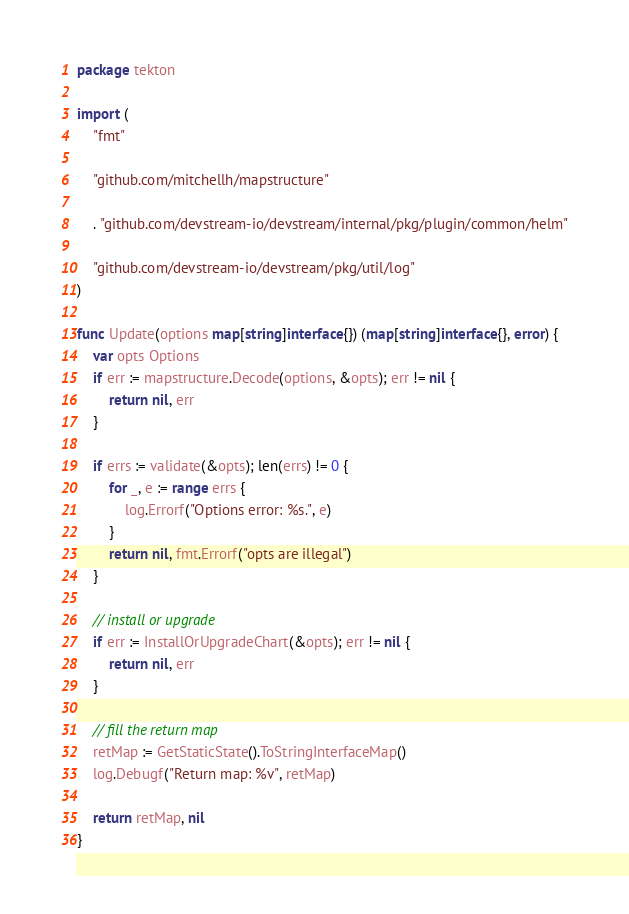<code> <loc_0><loc_0><loc_500><loc_500><_Go_>package tekton

import (
	"fmt"

	"github.com/mitchellh/mapstructure"

	. "github.com/devstream-io/devstream/internal/pkg/plugin/common/helm"

	"github.com/devstream-io/devstream/pkg/util/log"
)

func Update(options map[string]interface{}) (map[string]interface{}, error) {
	var opts Options
	if err := mapstructure.Decode(options, &opts); err != nil {
		return nil, err
	}

	if errs := validate(&opts); len(errs) != 0 {
		for _, e := range errs {
			log.Errorf("Options error: %s.", e)
		}
		return nil, fmt.Errorf("opts are illegal")
	}

	// install or upgrade
	if err := InstallOrUpgradeChart(&opts); err != nil {
		return nil, err
	}

	// fill the return map
	retMap := GetStaticState().ToStringInterfaceMap()
	log.Debugf("Return map: %v", retMap)

	return retMap, nil
}
</code> 